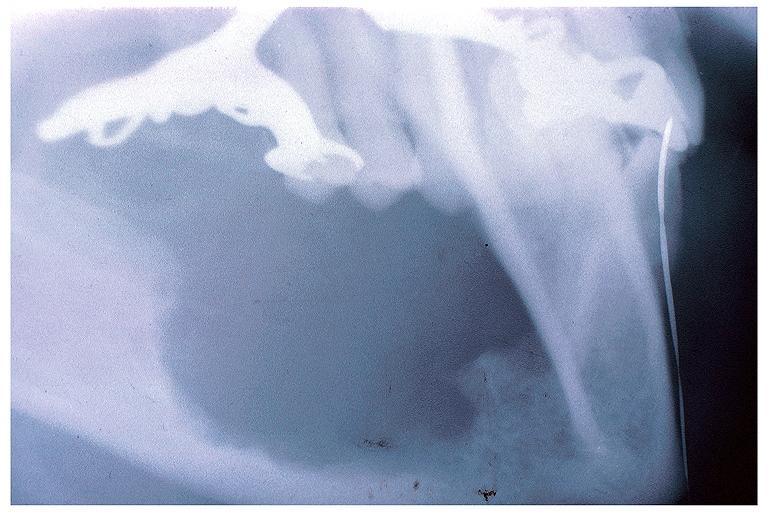what does this image show?
Answer the question using a single word or phrase. Intraosseous mucoepidermoid carcinoma 